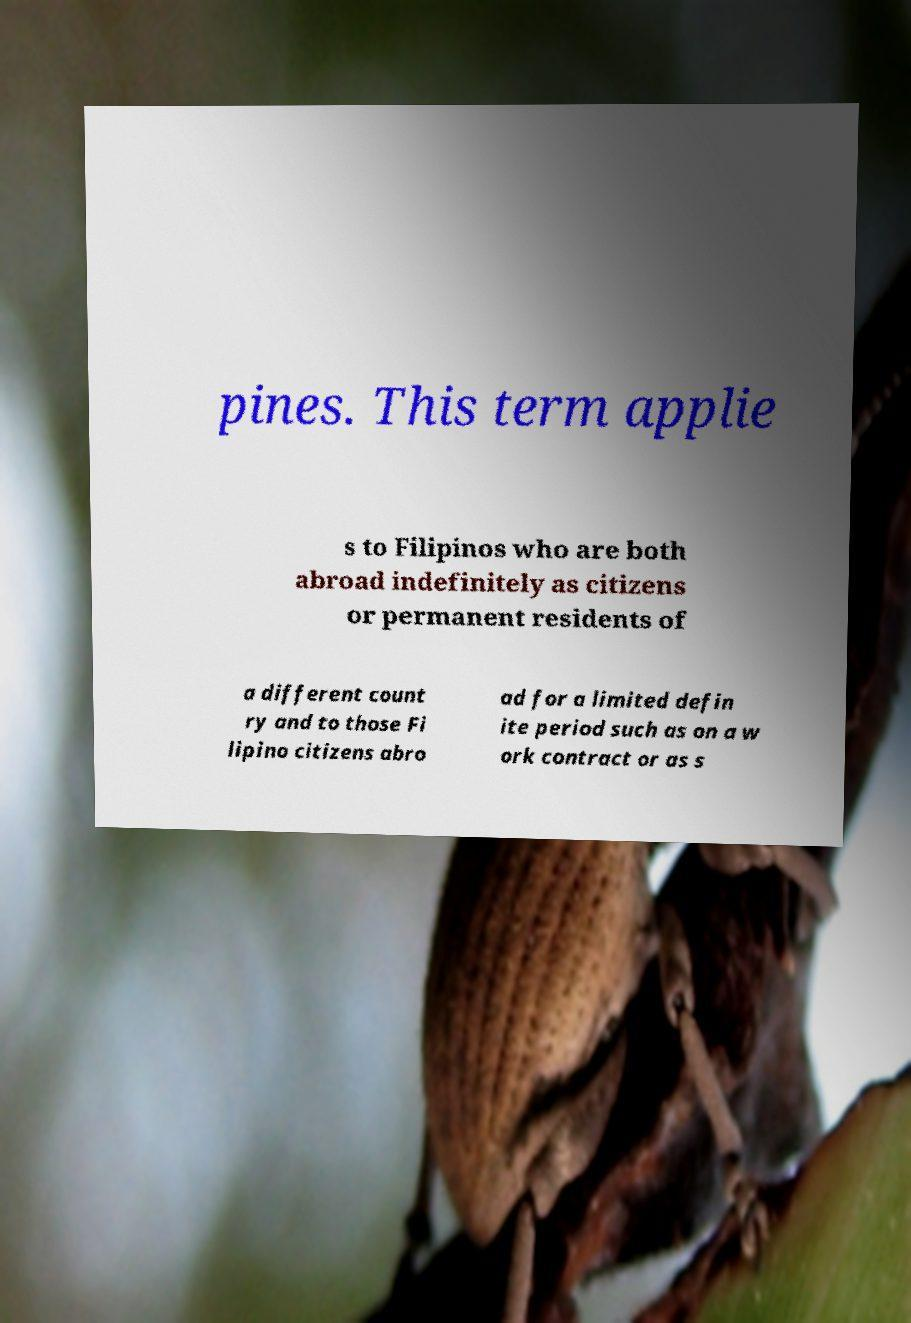For documentation purposes, I need the text within this image transcribed. Could you provide that? pines. This term applie s to Filipinos who are both abroad indefinitely as citizens or permanent residents of a different count ry and to those Fi lipino citizens abro ad for a limited defin ite period such as on a w ork contract or as s 